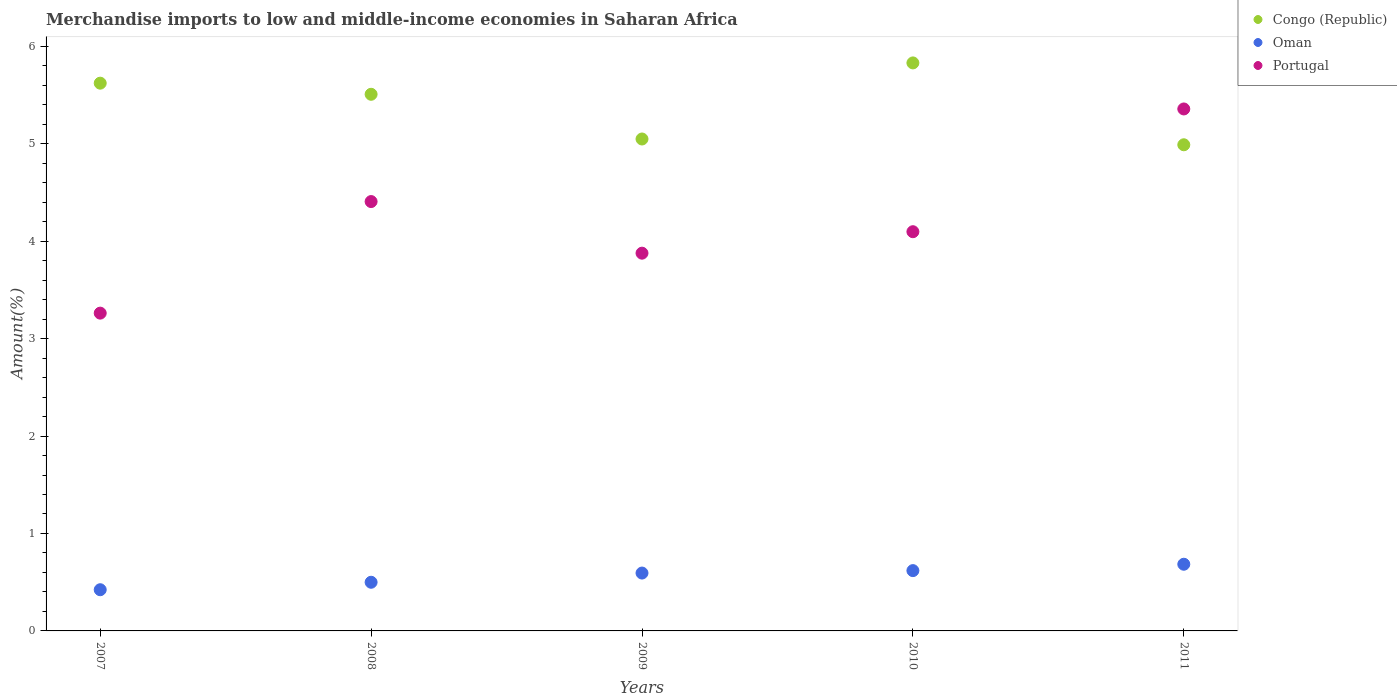How many different coloured dotlines are there?
Provide a short and direct response. 3. Is the number of dotlines equal to the number of legend labels?
Keep it short and to the point. Yes. What is the percentage of amount earned from merchandise imports in Congo (Republic) in 2007?
Your answer should be very brief. 5.62. Across all years, what is the maximum percentage of amount earned from merchandise imports in Portugal?
Your response must be concise. 5.36. Across all years, what is the minimum percentage of amount earned from merchandise imports in Oman?
Your answer should be very brief. 0.42. What is the total percentage of amount earned from merchandise imports in Congo (Republic) in the graph?
Offer a terse response. 26.99. What is the difference between the percentage of amount earned from merchandise imports in Portugal in 2007 and that in 2009?
Ensure brevity in your answer.  -0.62. What is the difference between the percentage of amount earned from merchandise imports in Oman in 2011 and the percentage of amount earned from merchandise imports in Portugal in 2007?
Your response must be concise. -2.58. What is the average percentage of amount earned from merchandise imports in Oman per year?
Offer a very short reply. 0.56. In the year 2008, what is the difference between the percentage of amount earned from merchandise imports in Oman and percentage of amount earned from merchandise imports in Congo (Republic)?
Your answer should be compact. -5.01. In how many years, is the percentage of amount earned from merchandise imports in Congo (Republic) greater than 2 %?
Provide a succinct answer. 5. What is the ratio of the percentage of amount earned from merchandise imports in Congo (Republic) in 2007 to that in 2009?
Offer a very short reply. 1.11. Is the percentage of amount earned from merchandise imports in Congo (Republic) in 2007 less than that in 2009?
Make the answer very short. No. Is the difference between the percentage of amount earned from merchandise imports in Oman in 2007 and 2011 greater than the difference between the percentage of amount earned from merchandise imports in Congo (Republic) in 2007 and 2011?
Keep it short and to the point. No. What is the difference between the highest and the second highest percentage of amount earned from merchandise imports in Congo (Republic)?
Keep it short and to the point. 0.21. What is the difference between the highest and the lowest percentage of amount earned from merchandise imports in Oman?
Keep it short and to the point. 0.26. In how many years, is the percentage of amount earned from merchandise imports in Congo (Republic) greater than the average percentage of amount earned from merchandise imports in Congo (Republic) taken over all years?
Your answer should be compact. 3. Is the sum of the percentage of amount earned from merchandise imports in Congo (Republic) in 2007 and 2008 greater than the maximum percentage of amount earned from merchandise imports in Portugal across all years?
Your answer should be very brief. Yes. Does the percentage of amount earned from merchandise imports in Oman monotonically increase over the years?
Provide a short and direct response. Yes. How many dotlines are there?
Give a very brief answer. 3. Does the graph contain any zero values?
Make the answer very short. No. Does the graph contain grids?
Keep it short and to the point. No. Where does the legend appear in the graph?
Keep it short and to the point. Top right. How are the legend labels stacked?
Provide a succinct answer. Vertical. What is the title of the graph?
Your answer should be compact. Merchandise imports to low and middle-income economies in Saharan Africa. What is the label or title of the X-axis?
Give a very brief answer. Years. What is the label or title of the Y-axis?
Your answer should be very brief. Amount(%). What is the Amount(%) of Congo (Republic) in 2007?
Your response must be concise. 5.62. What is the Amount(%) in Oman in 2007?
Your answer should be very brief. 0.42. What is the Amount(%) in Portugal in 2007?
Make the answer very short. 3.26. What is the Amount(%) of Congo (Republic) in 2008?
Offer a very short reply. 5.51. What is the Amount(%) of Oman in 2008?
Offer a terse response. 0.5. What is the Amount(%) in Portugal in 2008?
Offer a terse response. 4.41. What is the Amount(%) in Congo (Republic) in 2009?
Offer a terse response. 5.05. What is the Amount(%) of Oman in 2009?
Ensure brevity in your answer.  0.59. What is the Amount(%) in Portugal in 2009?
Provide a succinct answer. 3.88. What is the Amount(%) of Congo (Republic) in 2010?
Provide a short and direct response. 5.83. What is the Amount(%) in Oman in 2010?
Offer a terse response. 0.62. What is the Amount(%) of Portugal in 2010?
Give a very brief answer. 4.1. What is the Amount(%) in Congo (Republic) in 2011?
Offer a terse response. 4.99. What is the Amount(%) in Oman in 2011?
Your response must be concise. 0.68. What is the Amount(%) of Portugal in 2011?
Your response must be concise. 5.36. Across all years, what is the maximum Amount(%) in Congo (Republic)?
Provide a short and direct response. 5.83. Across all years, what is the maximum Amount(%) in Oman?
Your answer should be compact. 0.68. Across all years, what is the maximum Amount(%) in Portugal?
Your response must be concise. 5.36. Across all years, what is the minimum Amount(%) of Congo (Republic)?
Ensure brevity in your answer.  4.99. Across all years, what is the minimum Amount(%) in Oman?
Offer a very short reply. 0.42. Across all years, what is the minimum Amount(%) of Portugal?
Your response must be concise. 3.26. What is the total Amount(%) of Congo (Republic) in the graph?
Keep it short and to the point. 26.99. What is the total Amount(%) in Oman in the graph?
Provide a succinct answer. 2.82. What is the total Amount(%) of Portugal in the graph?
Your answer should be very brief. 21. What is the difference between the Amount(%) of Congo (Republic) in 2007 and that in 2008?
Your answer should be very brief. 0.11. What is the difference between the Amount(%) of Oman in 2007 and that in 2008?
Provide a short and direct response. -0.08. What is the difference between the Amount(%) of Portugal in 2007 and that in 2008?
Your answer should be very brief. -1.15. What is the difference between the Amount(%) of Congo (Republic) in 2007 and that in 2009?
Keep it short and to the point. 0.57. What is the difference between the Amount(%) of Oman in 2007 and that in 2009?
Make the answer very short. -0.17. What is the difference between the Amount(%) in Portugal in 2007 and that in 2009?
Ensure brevity in your answer.  -0.62. What is the difference between the Amount(%) in Congo (Republic) in 2007 and that in 2010?
Offer a terse response. -0.21. What is the difference between the Amount(%) in Oman in 2007 and that in 2010?
Make the answer very short. -0.2. What is the difference between the Amount(%) of Portugal in 2007 and that in 2010?
Provide a succinct answer. -0.84. What is the difference between the Amount(%) in Congo (Republic) in 2007 and that in 2011?
Ensure brevity in your answer.  0.63. What is the difference between the Amount(%) in Oman in 2007 and that in 2011?
Ensure brevity in your answer.  -0.26. What is the difference between the Amount(%) in Portugal in 2007 and that in 2011?
Your answer should be compact. -2.1. What is the difference between the Amount(%) of Congo (Republic) in 2008 and that in 2009?
Provide a succinct answer. 0.46. What is the difference between the Amount(%) of Oman in 2008 and that in 2009?
Keep it short and to the point. -0.09. What is the difference between the Amount(%) in Portugal in 2008 and that in 2009?
Offer a terse response. 0.53. What is the difference between the Amount(%) of Congo (Republic) in 2008 and that in 2010?
Provide a succinct answer. -0.32. What is the difference between the Amount(%) of Oman in 2008 and that in 2010?
Keep it short and to the point. -0.12. What is the difference between the Amount(%) in Portugal in 2008 and that in 2010?
Keep it short and to the point. 0.31. What is the difference between the Amount(%) of Congo (Republic) in 2008 and that in 2011?
Keep it short and to the point. 0.52. What is the difference between the Amount(%) in Oman in 2008 and that in 2011?
Offer a very short reply. -0.18. What is the difference between the Amount(%) in Portugal in 2008 and that in 2011?
Offer a very short reply. -0.95. What is the difference between the Amount(%) of Congo (Republic) in 2009 and that in 2010?
Keep it short and to the point. -0.78. What is the difference between the Amount(%) in Oman in 2009 and that in 2010?
Keep it short and to the point. -0.03. What is the difference between the Amount(%) in Portugal in 2009 and that in 2010?
Offer a terse response. -0.22. What is the difference between the Amount(%) of Congo (Republic) in 2009 and that in 2011?
Make the answer very short. 0.06. What is the difference between the Amount(%) of Oman in 2009 and that in 2011?
Your response must be concise. -0.09. What is the difference between the Amount(%) in Portugal in 2009 and that in 2011?
Your answer should be very brief. -1.48. What is the difference between the Amount(%) in Congo (Republic) in 2010 and that in 2011?
Provide a succinct answer. 0.84. What is the difference between the Amount(%) of Oman in 2010 and that in 2011?
Offer a terse response. -0.07. What is the difference between the Amount(%) in Portugal in 2010 and that in 2011?
Ensure brevity in your answer.  -1.26. What is the difference between the Amount(%) in Congo (Republic) in 2007 and the Amount(%) in Oman in 2008?
Your answer should be very brief. 5.12. What is the difference between the Amount(%) of Congo (Republic) in 2007 and the Amount(%) of Portugal in 2008?
Keep it short and to the point. 1.22. What is the difference between the Amount(%) in Oman in 2007 and the Amount(%) in Portugal in 2008?
Offer a terse response. -3.98. What is the difference between the Amount(%) in Congo (Republic) in 2007 and the Amount(%) in Oman in 2009?
Offer a terse response. 5.03. What is the difference between the Amount(%) of Congo (Republic) in 2007 and the Amount(%) of Portugal in 2009?
Ensure brevity in your answer.  1.74. What is the difference between the Amount(%) of Oman in 2007 and the Amount(%) of Portugal in 2009?
Offer a very short reply. -3.45. What is the difference between the Amount(%) in Congo (Republic) in 2007 and the Amount(%) in Oman in 2010?
Make the answer very short. 5. What is the difference between the Amount(%) in Congo (Republic) in 2007 and the Amount(%) in Portugal in 2010?
Your response must be concise. 1.52. What is the difference between the Amount(%) of Oman in 2007 and the Amount(%) of Portugal in 2010?
Your response must be concise. -3.67. What is the difference between the Amount(%) of Congo (Republic) in 2007 and the Amount(%) of Oman in 2011?
Keep it short and to the point. 4.94. What is the difference between the Amount(%) of Congo (Republic) in 2007 and the Amount(%) of Portugal in 2011?
Give a very brief answer. 0.26. What is the difference between the Amount(%) in Oman in 2007 and the Amount(%) in Portugal in 2011?
Provide a short and direct response. -4.93. What is the difference between the Amount(%) of Congo (Republic) in 2008 and the Amount(%) of Oman in 2009?
Your response must be concise. 4.91. What is the difference between the Amount(%) in Congo (Republic) in 2008 and the Amount(%) in Portugal in 2009?
Offer a very short reply. 1.63. What is the difference between the Amount(%) of Oman in 2008 and the Amount(%) of Portugal in 2009?
Make the answer very short. -3.38. What is the difference between the Amount(%) of Congo (Republic) in 2008 and the Amount(%) of Oman in 2010?
Keep it short and to the point. 4.89. What is the difference between the Amount(%) in Congo (Republic) in 2008 and the Amount(%) in Portugal in 2010?
Provide a succinct answer. 1.41. What is the difference between the Amount(%) in Oman in 2008 and the Amount(%) in Portugal in 2010?
Your answer should be compact. -3.6. What is the difference between the Amount(%) of Congo (Republic) in 2008 and the Amount(%) of Oman in 2011?
Your answer should be very brief. 4.82. What is the difference between the Amount(%) in Congo (Republic) in 2008 and the Amount(%) in Portugal in 2011?
Give a very brief answer. 0.15. What is the difference between the Amount(%) of Oman in 2008 and the Amount(%) of Portugal in 2011?
Offer a terse response. -4.86. What is the difference between the Amount(%) in Congo (Republic) in 2009 and the Amount(%) in Oman in 2010?
Provide a short and direct response. 4.43. What is the difference between the Amount(%) of Congo (Republic) in 2009 and the Amount(%) of Portugal in 2010?
Your response must be concise. 0.95. What is the difference between the Amount(%) of Oman in 2009 and the Amount(%) of Portugal in 2010?
Make the answer very short. -3.5. What is the difference between the Amount(%) of Congo (Republic) in 2009 and the Amount(%) of Oman in 2011?
Offer a very short reply. 4.36. What is the difference between the Amount(%) in Congo (Republic) in 2009 and the Amount(%) in Portugal in 2011?
Make the answer very short. -0.31. What is the difference between the Amount(%) of Oman in 2009 and the Amount(%) of Portugal in 2011?
Your response must be concise. -4.76. What is the difference between the Amount(%) of Congo (Republic) in 2010 and the Amount(%) of Oman in 2011?
Ensure brevity in your answer.  5.14. What is the difference between the Amount(%) of Congo (Republic) in 2010 and the Amount(%) of Portugal in 2011?
Offer a very short reply. 0.47. What is the difference between the Amount(%) of Oman in 2010 and the Amount(%) of Portugal in 2011?
Your answer should be compact. -4.74. What is the average Amount(%) of Congo (Republic) per year?
Provide a short and direct response. 5.4. What is the average Amount(%) of Oman per year?
Your response must be concise. 0.56. What is the average Amount(%) of Portugal per year?
Offer a terse response. 4.2. In the year 2007, what is the difference between the Amount(%) of Congo (Republic) and Amount(%) of Oman?
Your answer should be very brief. 5.2. In the year 2007, what is the difference between the Amount(%) in Congo (Republic) and Amount(%) in Portugal?
Your response must be concise. 2.36. In the year 2007, what is the difference between the Amount(%) in Oman and Amount(%) in Portugal?
Your answer should be very brief. -2.84. In the year 2008, what is the difference between the Amount(%) in Congo (Republic) and Amount(%) in Oman?
Keep it short and to the point. 5.01. In the year 2008, what is the difference between the Amount(%) of Congo (Republic) and Amount(%) of Portugal?
Keep it short and to the point. 1.1. In the year 2008, what is the difference between the Amount(%) in Oman and Amount(%) in Portugal?
Your answer should be very brief. -3.91. In the year 2009, what is the difference between the Amount(%) of Congo (Republic) and Amount(%) of Oman?
Offer a very short reply. 4.45. In the year 2009, what is the difference between the Amount(%) of Congo (Republic) and Amount(%) of Portugal?
Provide a succinct answer. 1.17. In the year 2009, what is the difference between the Amount(%) in Oman and Amount(%) in Portugal?
Ensure brevity in your answer.  -3.28. In the year 2010, what is the difference between the Amount(%) of Congo (Republic) and Amount(%) of Oman?
Keep it short and to the point. 5.21. In the year 2010, what is the difference between the Amount(%) in Congo (Republic) and Amount(%) in Portugal?
Ensure brevity in your answer.  1.73. In the year 2010, what is the difference between the Amount(%) of Oman and Amount(%) of Portugal?
Offer a very short reply. -3.48. In the year 2011, what is the difference between the Amount(%) in Congo (Republic) and Amount(%) in Oman?
Offer a very short reply. 4.3. In the year 2011, what is the difference between the Amount(%) in Congo (Republic) and Amount(%) in Portugal?
Provide a short and direct response. -0.37. In the year 2011, what is the difference between the Amount(%) in Oman and Amount(%) in Portugal?
Make the answer very short. -4.67. What is the ratio of the Amount(%) of Congo (Republic) in 2007 to that in 2008?
Offer a terse response. 1.02. What is the ratio of the Amount(%) of Oman in 2007 to that in 2008?
Keep it short and to the point. 0.85. What is the ratio of the Amount(%) of Portugal in 2007 to that in 2008?
Your answer should be compact. 0.74. What is the ratio of the Amount(%) of Congo (Republic) in 2007 to that in 2009?
Give a very brief answer. 1.11. What is the ratio of the Amount(%) in Oman in 2007 to that in 2009?
Provide a short and direct response. 0.71. What is the ratio of the Amount(%) of Portugal in 2007 to that in 2009?
Offer a terse response. 0.84. What is the ratio of the Amount(%) in Oman in 2007 to that in 2010?
Provide a succinct answer. 0.68. What is the ratio of the Amount(%) in Portugal in 2007 to that in 2010?
Make the answer very short. 0.8. What is the ratio of the Amount(%) in Congo (Republic) in 2007 to that in 2011?
Provide a succinct answer. 1.13. What is the ratio of the Amount(%) of Oman in 2007 to that in 2011?
Offer a very short reply. 0.62. What is the ratio of the Amount(%) in Portugal in 2007 to that in 2011?
Make the answer very short. 0.61. What is the ratio of the Amount(%) in Oman in 2008 to that in 2009?
Offer a terse response. 0.84. What is the ratio of the Amount(%) of Portugal in 2008 to that in 2009?
Make the answer very short. 1.14. What is the ratio of the Amount(%) of Congo (Republic) in 2008 to that in 2010?
Keep it short and to the point. 0.94. What is the ratio of the Amount(%) of Oman in 2008 to that in 2010?
Your answer should be compact. 0.81. What is the ratio of the Amount(%) in Portugal in 2008 to that in 2010?
Your answer should be very brief. 1.08. What is the ratio of the Amount(%) in Congo (Republic) in 2008 to that in 2011?
Offer a terse response. 1.1. What is the ratio of the Amount(%) in Oman in 2008 to that in 2011?
Give a very brief answer. 0.73. What is the ratio of the Amount(%) in Portugal in 2008 to that in 2011?
Offer a very short reply. 0.82. What is the ratio of the Amount(%) of Congo (Republic) in 2009 to that in 2010?
Your answer should be compact. 0.87. What is the ratio of the Amount(%) of Oman in 2009 to that in 2010?
Offer a terse response. 0.96. What is the ratio of the Amount(%) in Portugal in 2009 to that in 2010?
Offer a terse response. 0.95. What is the ratio of the Amount(%) in Congo (Republic) in 2009 to that in 2011?
Give a very brief answer. 1.01. What is the ratio of the Amount(%) in Oman in 2009 to that in 2011?
Give a very brief answer. 0.87. What is the ratio of the Amount(%) of Portugal in 2009 to that in 2011?
Your response must be concise. 0.72. What is the ratio of the Amount(%) in Congo (Republic) in 2010 to that in 2011?
Make the answer very short. 1.17. What is the ratio of the Amount(%) in Oman in 2010 to that in 2011?
Provide a succinct answer. 0.9. What is the ratio of the Amount(%) of Portugal in 2010 to that in 2011?
Make the answer very short. 0.76. What is the difference between the highest and the second highest Amount(%) of Congo (Republic)?
Offer a terse response. 0.21. What is the difference between the highest and the second highest Amount(%) of Oman?
Your answer should be very brief. 0.07. What is the difference between the highest and the second highest Amount(%) in Portugal?
Provide a succinct answer. 0.95. What is the difference between the highest and the lowest Amount(%) in Congo (Republic)?
Your answer should be compact. 0.84. What is the difference between the highest and the lowest Amount(%) in Oman?
Offer a terse response. 0.26. What is the difference between the highest and the lowest Amount(%) in Portugal?
Keep it short and to the point. 2.1. 